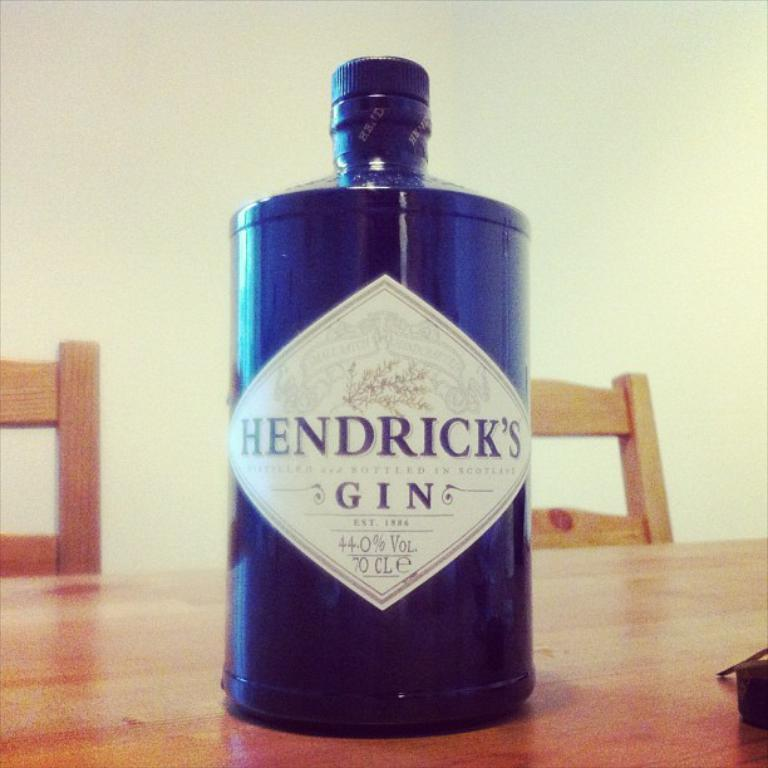<image>
Offer a succinct explanation of the picture presented. A dark colored bottle of Hendrick's Gin with a white diamond shaped label and black text. 